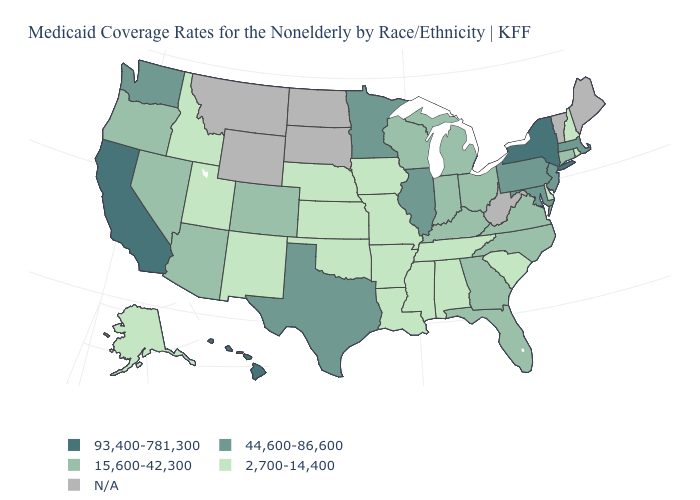Name the states that have a value in the range 2,700-14,400?
Write a very short answer. Alabama, Alaska, Arkansas, Delaware, Idaho, Iowa, Kansas, Louisiana, Mississippi, Missouri, Nebraska, New Hampshire, New Mexico, Oklahoma, Rhode Island, South Carolina, Tennessee, Utah. What is the value of California?
Quick response, please. 93,400-781,300. Name the states that have a value in the range N/A?
Give a very brief answer. Maine, Montana, North Dakota, South Dakota, Vermont, West Virginia, Wyoming. Does the map have missing data?
Short answer required. Yes. Is the legend a continuous bar?
Answer briefly. No. What is the lowest value in states that border New York?
Give a very brief answer. 15,600-42,300. What is the lowest value in the USA?
Write a very short answer. 2,700-14,400. What is the lowest value in the USA?
Concise answer only. 2,700-14,400. Which states have the lowest value in the USA?
Write a very short answer. Alabama, Alaska, Arkansas, Delaware, Idaho, Iowa, Kansas, Louisiana, Mississippi, Missouri, Nebraska, New Hampshire, New Mexico, Oklahoma, Rhode Island, South Carolina, Tennessee, Utah. What is the value of Kentucky?
Write a very short answer. 15,600-42,300. Among the states that border Minnesota , does Iowa have the highest value?
Short answer required. No. Name the states that have a value in the range 93,400-781,300?
Answer briefly. California, Hawaii, New York. 